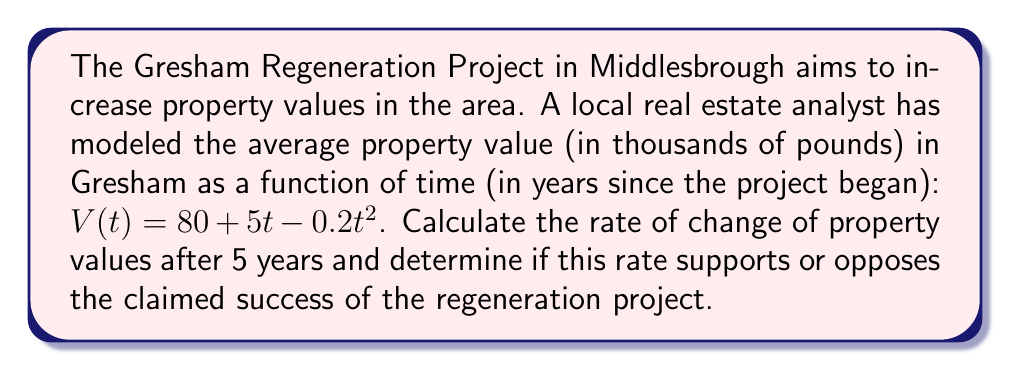Could you help me with this problem? To analyze the rate of change in property values, we need to use derivatives. The rate of change at any given time is represented by the first derivative of the function.

1) First, let's find the derivative of $V(t)$:
   $$V(t) = 80 + 5t - 0.2t^2$$
   $$V'(t) = 5 - 0.4t$$

2) Now, we want to find the rate of change after 5 years, so we'll evaluate $V'(5)$:
   $$V'(5) = 5 - 0.4(5) = 5 - 2 = 3$$

3) This means that after 5 years, the rate of change of property values is £3,000 per year.

4) To determine if this supports or opposes the claimed success of the project, we need to consider the context:
   - A positive rate of change (£3,000/year) indicates that property values are still increasing.
   - However, the original function $V(t)$ is quadratic with a negative coefficient for $t^2$, which means the rate of increase is slowing down over time.
   - The maximum value of $V(t)$ occurs when $V'(t) = 0$:
     $$5 - 0.4t = 0$$
     $$t = 12.5$$

5) This means that property values will stop increasing after 12.5 years, and then start to decrease.

Given this analysis, while the current rate of change is positive, the long-term trajectory suggests that the benefits of the regeneration project may be temporary, potentially supporting arguments against the project's claimed long-term success.
Answer: The rate of change of property values after 5 years is £3,000 per year. While this positive rate initially seems to support the project's success, the declining rate of increase and eventual decrease in property values after 12.5 years could be used to argue against the long-term effectiveness of the Gresham Regeneration Project. 